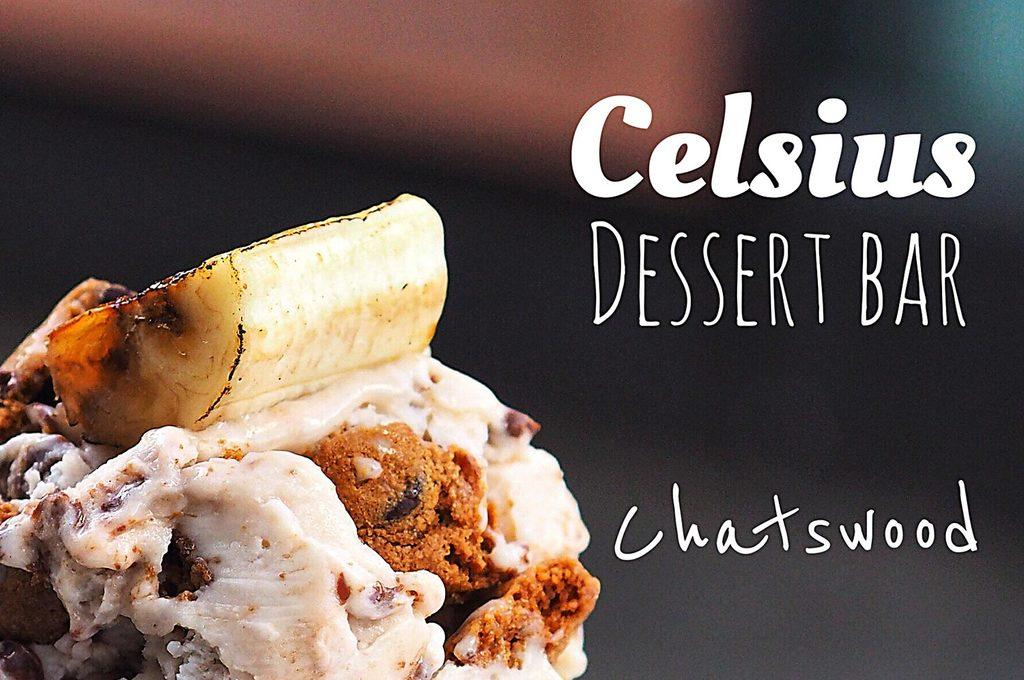What can be observed about the image's appearance? The image is edited. What is located on the left side of the image? There is a food item on the left side of the image. What is present on the right side of the image? There is text written on the right side of the image. What color is the background of the image? The background of the image is black. How does the maid interact with the stem in the image? There is no maid or stem present in the image. What type of competition is taking place in the image? There is no competition present in the image. 